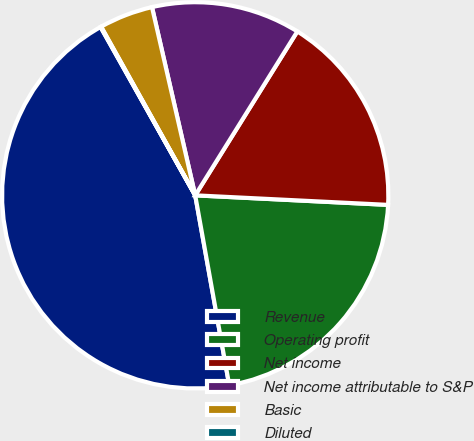<chart> <loc_0><loc_0><loc_500><loc_500><pie_chart><fcel>Revenue<fcel>Operating profit<fcel>Net income<fcel>Net income attributable to S&P<fcel>Basic<fcel>Diluted<nl><fcel>44.67%<fcel>21.39%<fcel>16.92%<fcel>12.46%<fcel>4.51%<fcel>0.05%<nl></chart> 